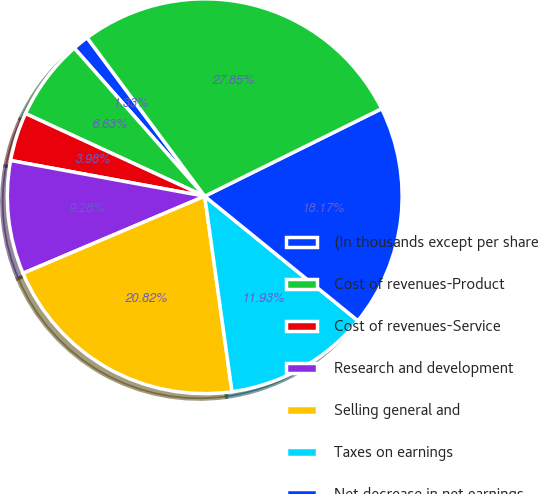<chart> <loc_0><loc_0><loc_500><loc_500><pie_chart><fcel>(In thousands except per share<fcel>Cost of revenues-Product<fcel>Cost of revenues-Service<fcel>Research and development<fcel>Selling general and<fcel>Taxes on earnings<fcel>Net decrease in net earnings<fcel>Cash flows from financing<nl><fcel>1.33%<fcel>6.63%<fcel>3.98%<fcel>9.28%<fcel>20.82%<fcel>11.93%<fcel>18.17%<fcel>27.84%<nl></chart> 